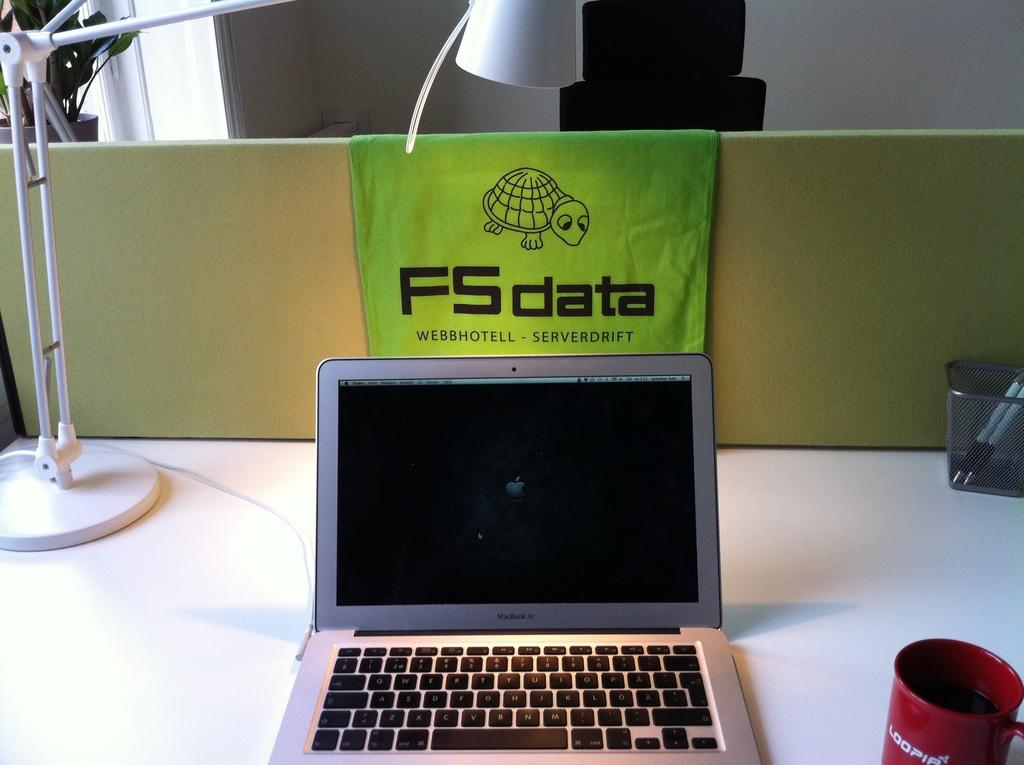Provide a one-sentence caption for the provided image. A laptop on a desk with a green FS data towel draped over the back. 